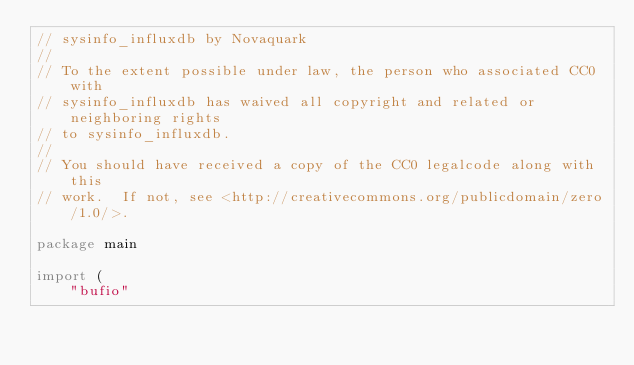Convert code to text. <code><loc_0><loc_0><loc_500><loc_500><_Go_>// sysinfo_influxdb by Novaquark
//
// To the extent possible under law, the person who associated CC0 with
// sysinfo_influxdb has waived all copyright and related or neighboring rights
// to sysinfo_influxdb.
//
// You should have received a copy of the CC0 legalcode along with this
// work.  If not, see <http://creativecommons.org/publicdomain/zero/1.0/>.

package main

import (
	"bufio"</code> 